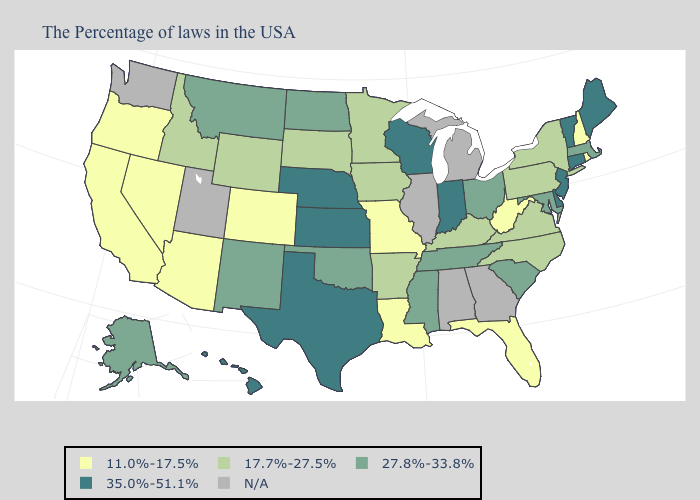How many symbols are there in the legend?
Keep it brief. 5. Among the states that border Tennessee , which have the lowest value?
Quick response, please. Missouri. What is the value of Michigan?
Give a very brief answer. N/A. Does Indiana have the highest value in the USA?
Be succinct. Yes. Does California have the highest value in the USA?
Quick response, please. No. Name the states that have a value in the range N/A?
Concise answer only. Georgia, Michigan, Alabama, Illinois, Utah, Washington. Does Oregon have the lowest value in the USA?
Answer briefly. Yes. Does Louisiana have the lowest value in the USA?
Answer briefly. Yes. Among the states that border North Carolina , does Tennessee have the lowest value?
Quick response, please. No. Does Minnesota have the lowest value in the USA?
Quick response, please. No. Is the legend a continuous bar?
Short answer required. No. Does South Dakota have the lowest value in the USA?
Give a very brief answer. No. Does California have the highest value in the West?
Keep it brief. No. What is the value of Utah?
Keep it brief. N/A. Does Rhode Island have the lowest value in the USA?
Answer briefly. Yes. 